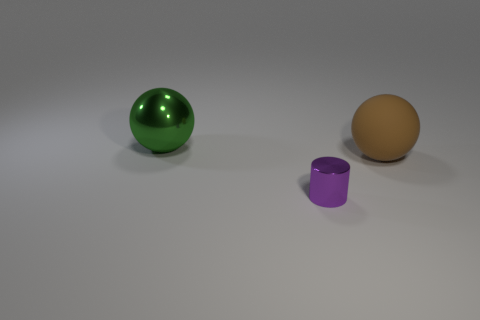Are there any other things that are the same size as the purple cylinder?
Offer a terse response. No. What is the shape of the small object?
Offer a terse response. Cylinder. There is a large green thing; does it have the same shape as the metallic object that is in front of the big brown rubber ball?
Offer a very short reply. No. Do the big object that is to the left of the purple thing and the purple thing have the same shape?
Provide a succinct answer. No. What number of balls are on the left side of the rubber object and to the right of the purple metallic thing?
Offer a terse response. 0. What number of other things are there of the same size as the brown matte ball?
Offer a terse response. 1. Are there an equal number of spheres that are in front of the small cylinder and green metal objects?
Give a very brief answer. No. There is a sphere on the right side of the large green shiny ball; does it have the same color as the sphere to the left of the purple cylinder?
Your response must be concise. No. What material is the object that is on the left side of the large rubber thing and on the right side of the large green sphere?
Offer a terse response. Metal. The small metal cylinder is what color?
Keep it short and to the point. Purple. 